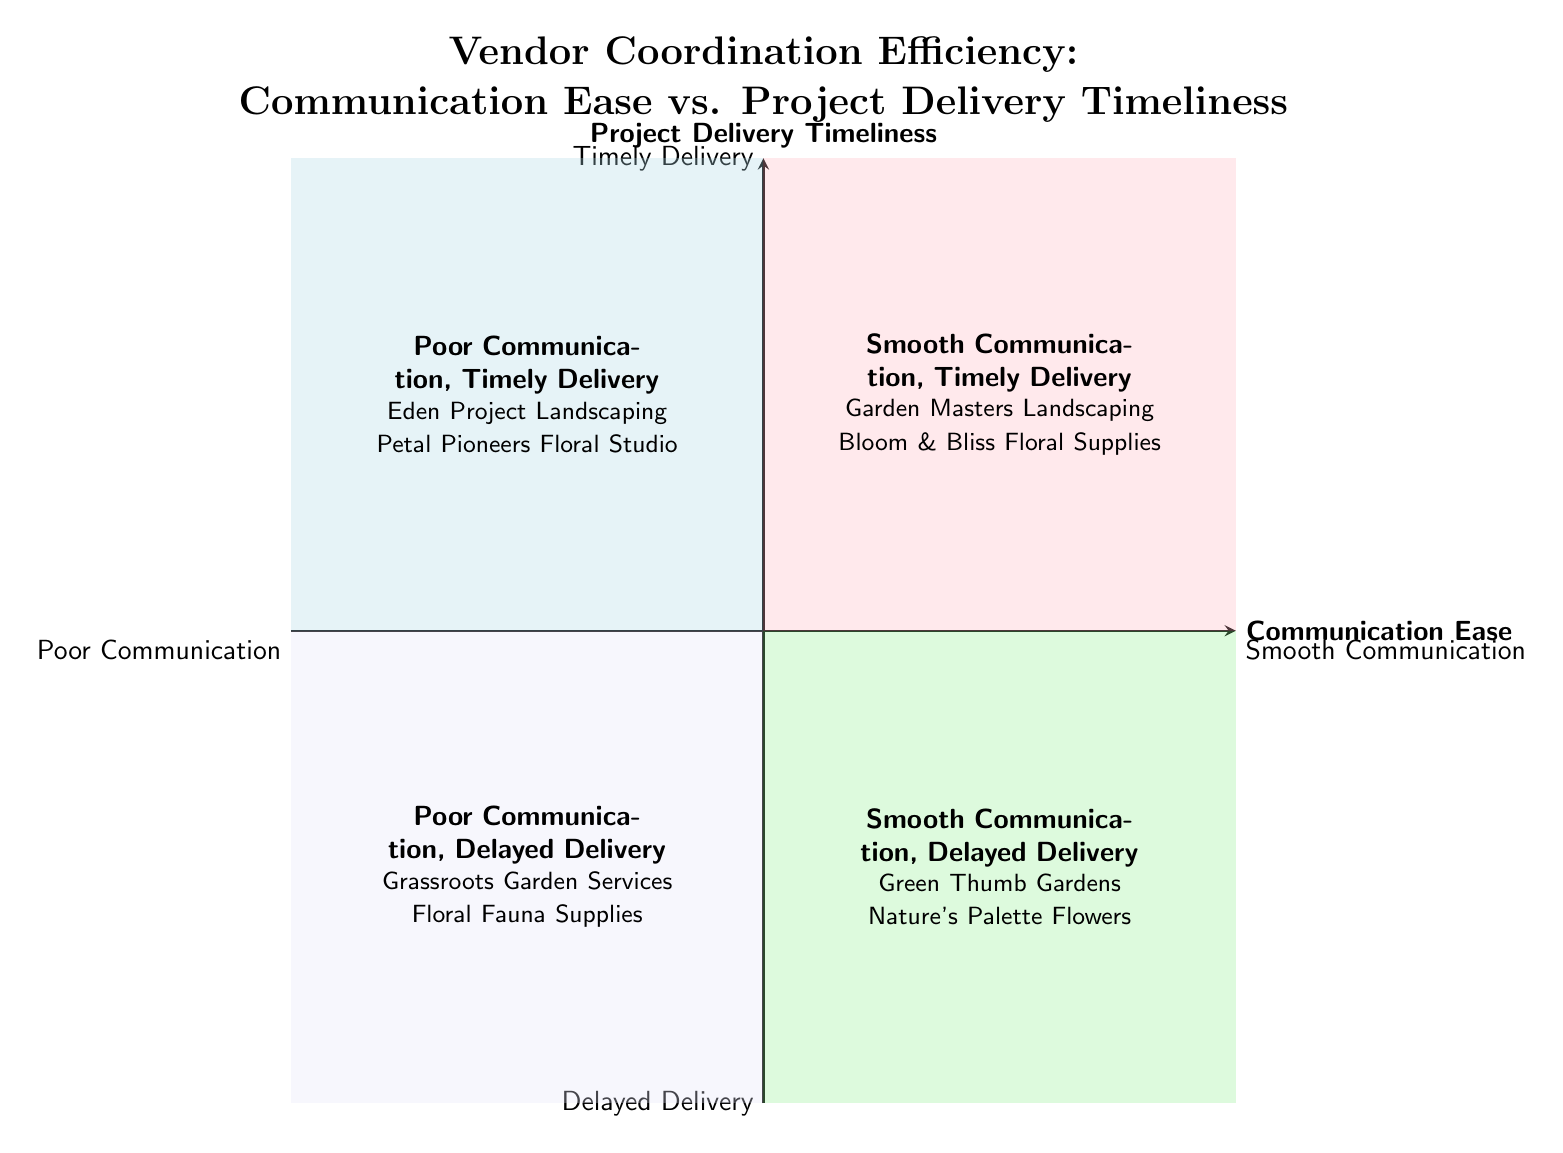What are the two vendors in the quadrant labeled "Smooth Communication, Timely Delivery"? This quadrant contains two specific examples of vendors: Garden Masters Landscaping and Bloom & Bliss Floral Supplies.
Answer: Garden Masters Landscaping, Bloom & Bliss Floral Supplies Which quadrant includes vendors with poor communication but timely delivery? The quadrant for vendors with poor communication but timely delivery is labeled "Poor Communication, Timely Delivery." It contains vendors like Eden Project Landscaping and Petal Pioneers Floral Studio.
Answer: Poor Communication, Timely Delivery What is the primary description for the "Smooth Communication, Delayed Delivery" quadrant? The primary description for this quadrant is that it includes vendors who are easy to communicate with but often have issues meeting their delivery timelines, thus requiring more follow-ups and contingency planning.
Answer: Vendors easy to communicate with, delayed delivery How many vendors are listed in the "Poor Communication, Delayed Delivery" quadrant? This quadrant specifically lists two vendors: Grassroots Garden Services and Floral Fauna Supplies, totaling to two vendors.
Answer: 2 In terms of project delivery, which quadrant represents the vendors who struggle with both communication and delivery? The quadrant representing vendors who struggle with both communication and delivery is labeled "Poor Communication, Delayed Delivery."
Answer: Poor Communication, Delayed Delivery Which quadrant would you prefer for a stress-free wedding planning process? The preferred quadrant for a stress-free wedding planning process is "Smooth Communication, Timely Delivery," as it indicates vendors who are reliable in both communication and delivery.
Answer: Smooth Communication, Timely Delivery How do the descriptions of "Smooth Communication, Timely Delivery" and "Poor Communication, Timely Delivery" contrast regarding coordination challenges? The first quadrant (Smooth Communication, Timely Delivery) implies a stress-free process, while the second (Poor Communication, Timely Delivery) indicates issues in coordination despite timely delivery.
Answer: Coordination challenges contrast in reliability What does the y-axis represent in the quadrant chart? The y-axis represents "Project Delivery Timeliness," ranging from Delayed Delivery at the bottom to Timely Delivery at the top.
Answer: Project Delivery Timeliness 